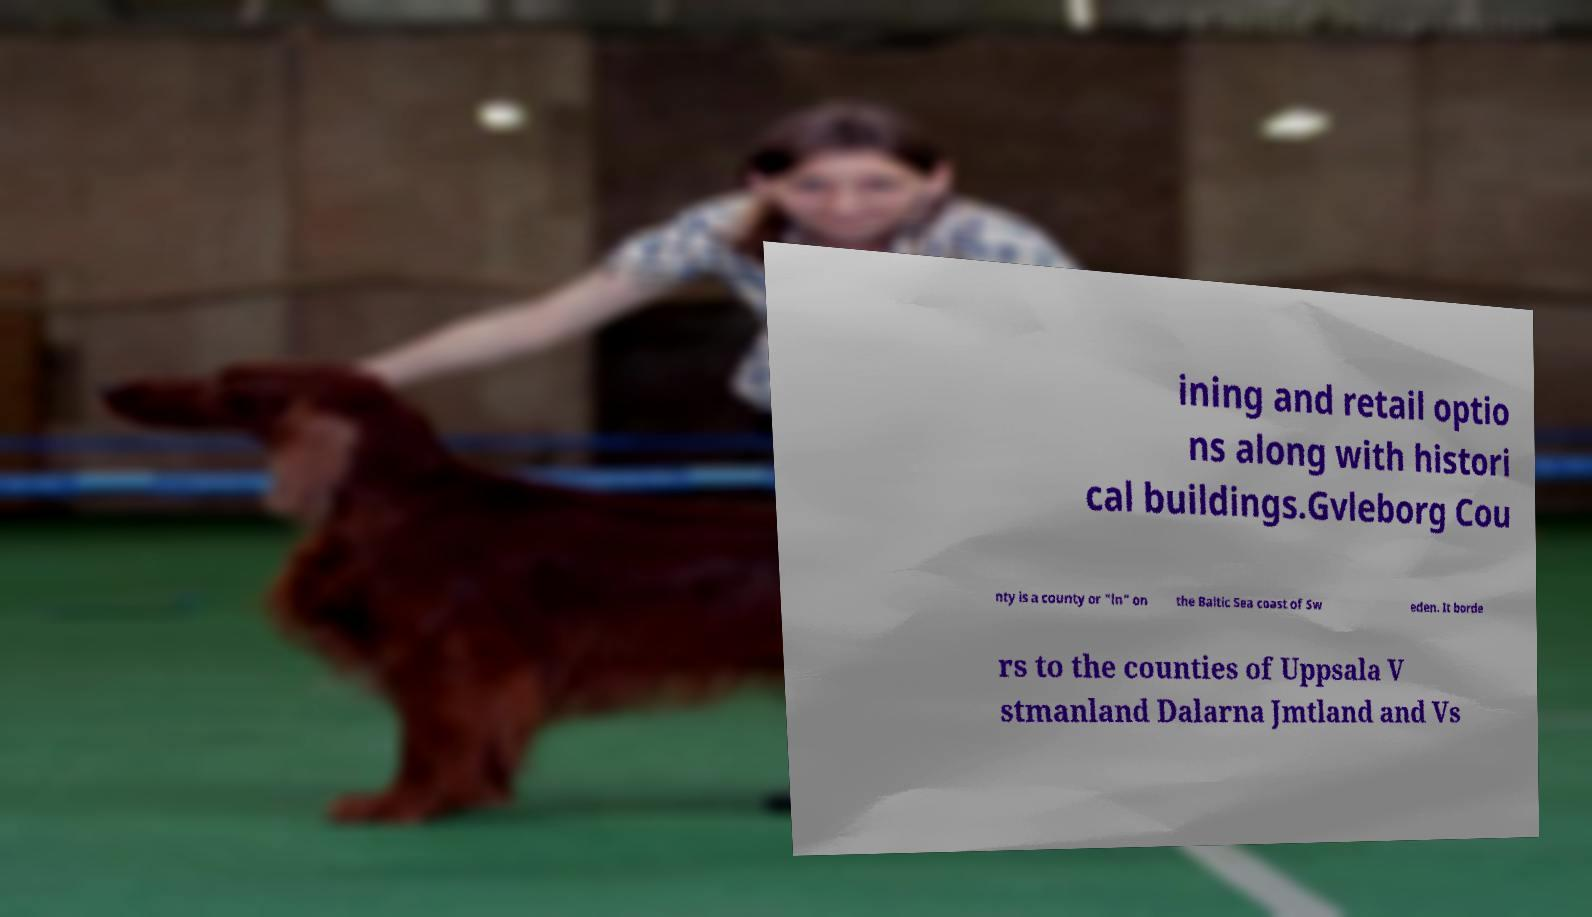I need the written content from this picture converted into text. Can you do that? ining and retail optio ns along with histori cal buildings.Gvleborg Cou nty is a county or "ln" on the Baltic Sea coast of Sw eden. It borde rs to the counties of Uppsala V stmanland Dalarna Jmtland and Vs 